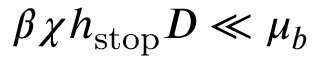Convert formula to latex. <formula><loc_0><loc_0><loc_500><loc_500>\beta \chi h _ { s t o p } D \ll \mu _ { b }</formula> 